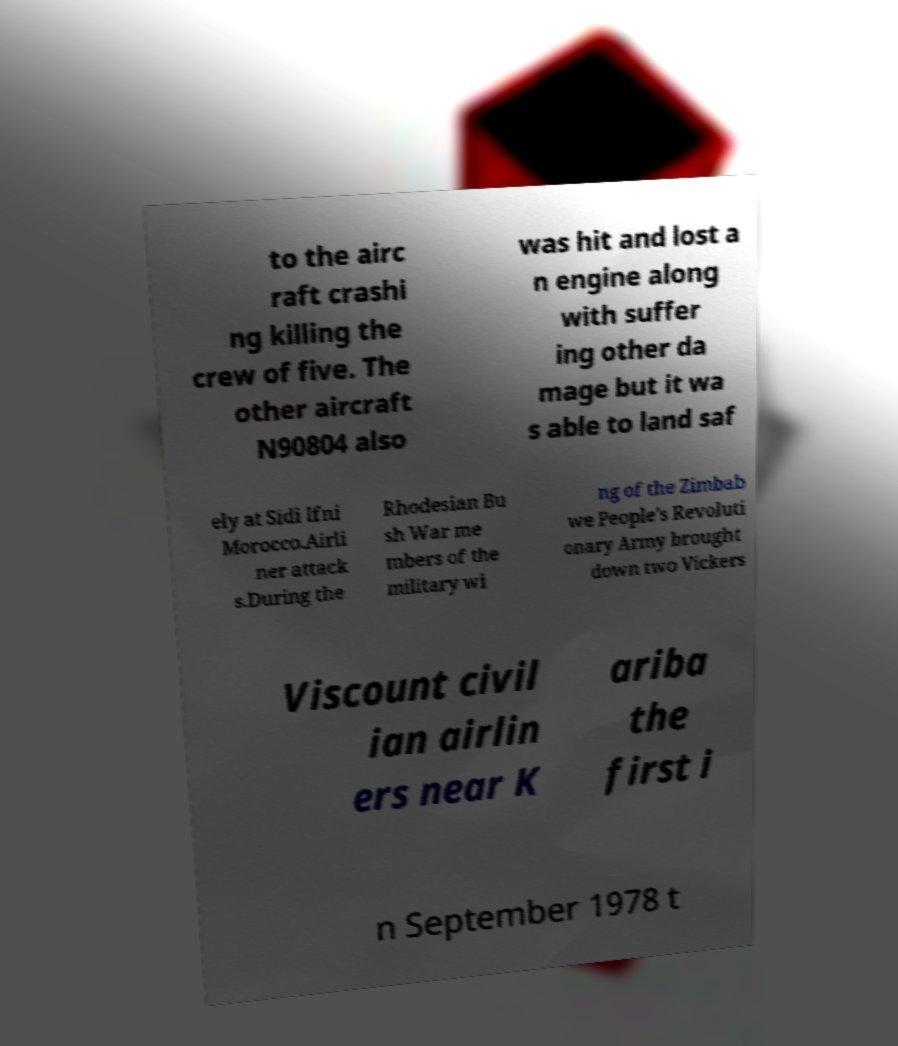Can you read and provide the text displayed in the image?This photo seems to have some interesting text. Can you extract and type it out for me? to the airc raft crashi ng killing the crew of five. The other aircraft N90804 also was hit and lost a n engine along with suffer ing other da mage but it wa s able to land saf ely at Sidi Ifni Morocco.Airli ner attack s.During the Rhodesian Bu sh War me mbers of the military wi ng of the Zimbab we People's Revoluti onary Army brought down two Vickers Viscount civil ian airlin ers near K ariba the first i n September 1978 t 